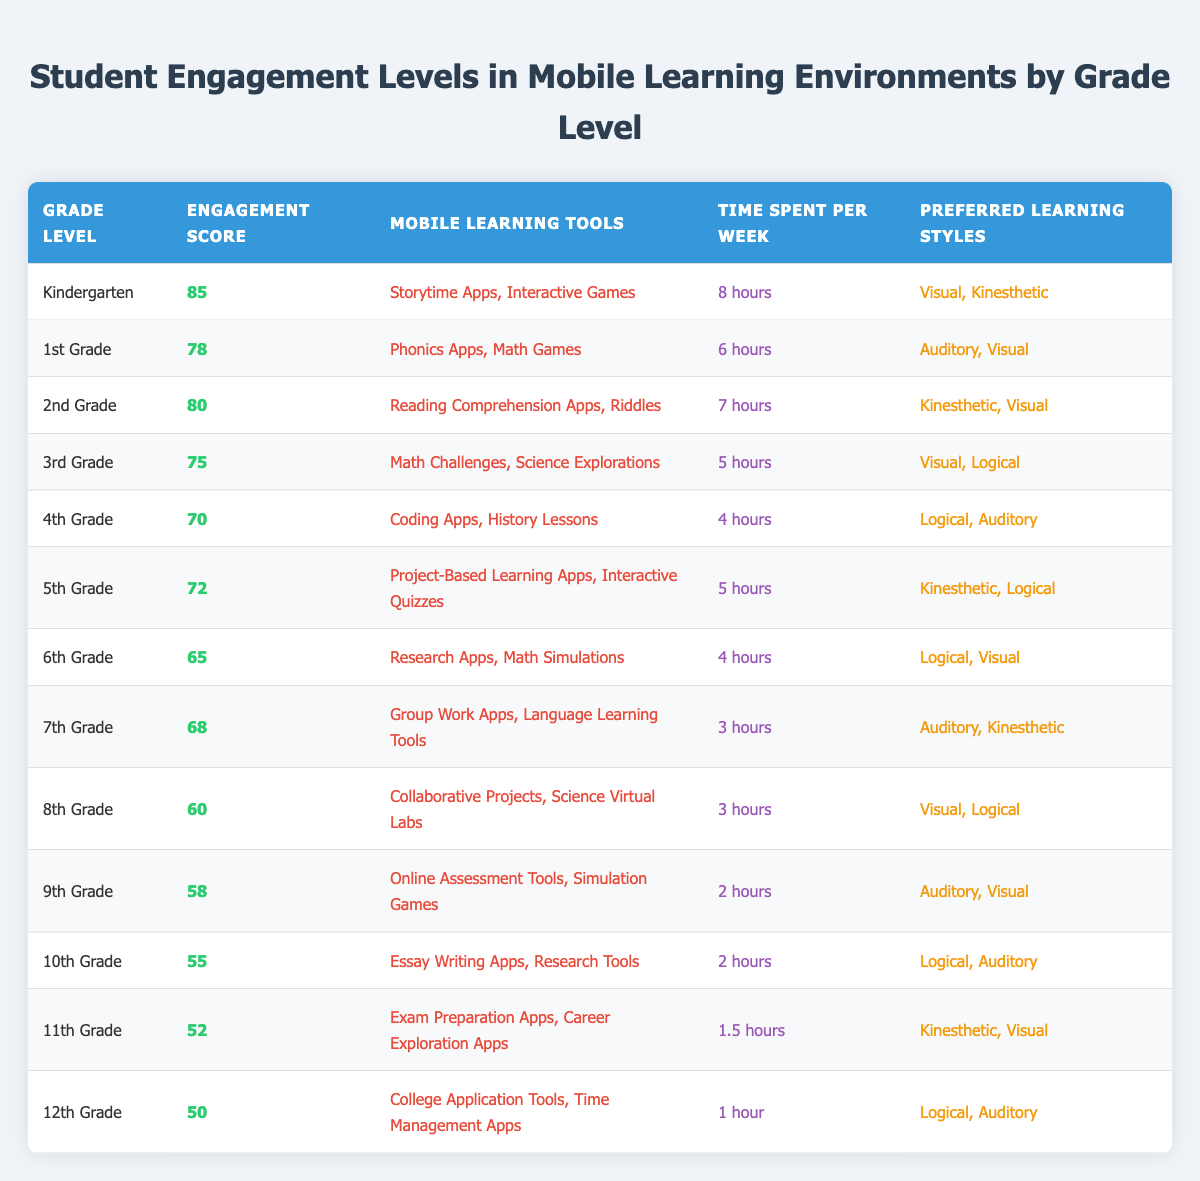What is the engagement score for 5th Grade? The engagement score for 5th Grade is directly listed in the table under the Engagement Score column for that grade level. It is 72.
Answer: 72 Which grade level has the highest engagement score? By examining the Engagement Score column, Kindergarten has the highest score at 85, compared to other grade levels.
Answer: Kindergarten What are the mobile learning tools used by 4th Grade? The mobile learning tools for 4th Grade are listed in the Mobile Learning Tools column as Coding Apps and History Lessons.
Answer: Coding Apps, History Lessons Which grade spends the most time on mobile learning per week and how many hours? Looking through the Time Spent Per Week column, Kindergarten spends the most time at 8 hours per week. This is the highest value in that column.
Answer: Kindergarten, 8 hours Is the preferred learning style for 12th Grade mainly visual? Checking the Preferred Learning Styles column for 12th Grade, it includes Logical and Auditory, but not Visual. Thus, the statement is false.
Answer: No What is the average engagement score for middle school grades (6th to 8th Grade)? The engagement scores for 6th, 7th, and 8th Grade are 65, 68, and 60 respectively. To find the average, sum them (65 + 68 + 60 = 193) and divide by 3, which gives 193 / 3 = 64.33. Rounded off, this is 64.
Answer: 64.33 How does the engagement score for 9th Grade compare with that of 11th Grade? By comparing the Engagement Score column, 9th Grade has a score of 58 while 11th Grade has 52. Therefore, 9th Grade has a higher engagement score than 11th Grade.
Answer: Higher Which grade levels use Kinesthetic as a preferred learning style? Reviewing the Preferred Learning Styles column, Kinesthetic is mentioned for Kindergarten, 2nd Grade, 5th Grade, and 11th Grade. These are the grade levels that include it.
Answer: Kindergarten, 2nd Grade, 5th Grade, 11th Grade What is the difference in hours spent on mobile learning between 1st Grade and 3rd Grade? First, note the Time Spent Per Week: 1st Grade is 6 hours and 3rd Grade is 5 hours. The difference is calculated by subtracting 5 from 6, which equals 1 hour.
Answer: 1 hour 